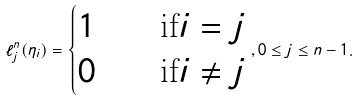Convert formula to latex. <formula><loc_0><loc_0><loc_500><loc_500>\ell _ { j } ^ { n } ( \eta _ { i } ) = \begin{cases} 1 & \quad \text {if} i = j \\ 0 & \quad \text {if} i \neq j \end{cases} , 0 \leq j \leq n - 1 .</formula> 